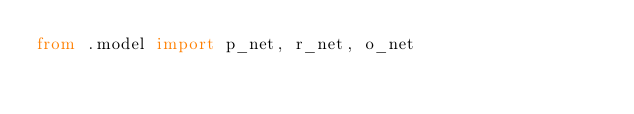<code> <loc_0><loc_0><loc_500><loc_500><_Python_>from .model import p_net, r_net, o_net
</code> 